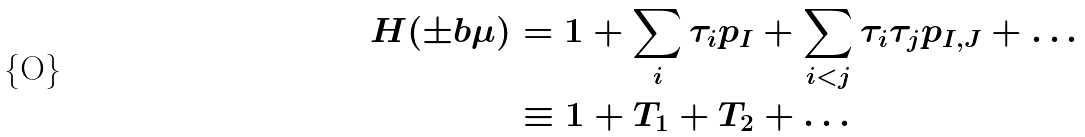Convert formula to latex. <formula><loc_0><loc_0><loc_500><loc_500>H ( \pm b { \mu } ) & = 1 + \sum _ { i } \tau _ { i } p _ { I } + \sum _ { i < j } \tau _ { i } \tau _ { j } p _ { I , J } + \dots \\ & \equiv 1 + T _ { 1 } + T _ { 2 } + \dots</formula> 